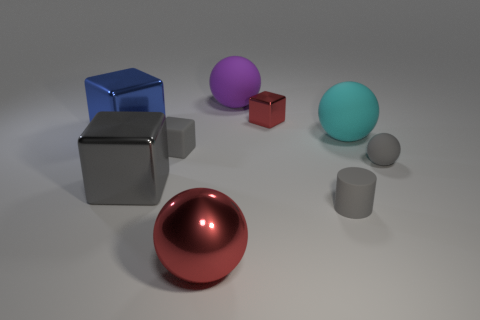There is a large red shiny thing that is right of the tiny block to the left of the sphere that is behind the blue block; what shape is it?
Your answer should be compact. Sphere. Does the big thing in front of the tiny gray cylinder have the same color as the metallic object that is right of the big purple sphere?
Make the answer very short. Yes. Is the number of tiny metal things on the left side of the large red object less than the number of small gray matte things left of the tiny matte sphere?
Provide a short and direct response. Yes. There is another tiny thing that is the same shape as the small red thing; what color is it?
Your answer should be very brief. Gray. Does the gray shiny thing have the same shape as the red metallic thing that is behind the gray shiny cube?
Offer a terse response. Yes. What number of things are gray objects in front of the gray metal thing or objects that are to the left of the purple object?
Offer a terse response. 5. What is the material of the small red thing?
Your answer should be very brief. Metal. How many other objects are the same size as the gray rubber cylinder?
Offer a terse response. 3. There is a ball that is to the left of the purple matte thing; what is its size?
Ensure brevity in your answer.  Large. What is the material of the small sphere in front of the small gray matte object that is to the left of the large red metal ball in front of the gray sphere?
Offer a terse response. Rubber. 